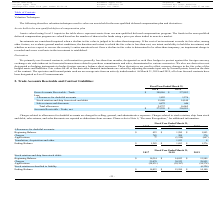According to Avx Corporation's financial document, Where are charges related to allowances for doubtful accounts are charged to? Charged to selling, general, and administrative expenses. The document states: "s related to allowances for doubtful accounts are charged to selling, general, and administrative expenses. Charges related to stock rotation, ship fr..." Also, Where are charges related to stock rotation, ship from stock and debit, sales returns, and sales discounts are reported as? Reported as deductions from revenue.. The document states: "and debit, sales returns, and sales discounts are reported as deductions from revenue. Please refer to Note 6, “Revenue Recognition,” for additional i..." Also, What is the company's allowances for doubtful accounts in 2019? According to the financial document, 1,276. The relevant text states: "Allowances for doubtful accounts 1,893 1,276..." Also, can you calculate: What is the total allowances for doubtful accounts in 2018 and 2019? Based on the calculation: 1,893 + 1,276 , the result is 3169. This is based on the information: "Allowances for doubtful accounts 1,893 1,276 Allowances for doubtful accounts 1,893 1,276..." The key data points involved are: 1,276, 1,893. Also, can you calculate: What is the percentage change in net accounts receivable - trade between 2018 and 2019? To answer this question, I need to perform calculations using the financial data. The calculation is: (256,991 - 275,259)/275,259 , which equals -6.64 (percentage). This is based on the information: "Accounts Receivable - Trade, net $ 275,259 $ 256,991 Accounts Receivable - Trade, net $ 275,259 $ 256,991..." The key data points involved are: 256,991, 275,259. Also, can you calculate: What is the total allowances in 2018 as a percentage of the gross accounts receivable - trade? Based on the calculation: 24,757/300,016 , the result is 8.25 (percentage). This is based on the information: "Gross Accounts Receivable - Trade $ 300,016 $ 273,053 Total allowances 24,757 16,062..." The key data points involved are: 24,757, 300,016. 